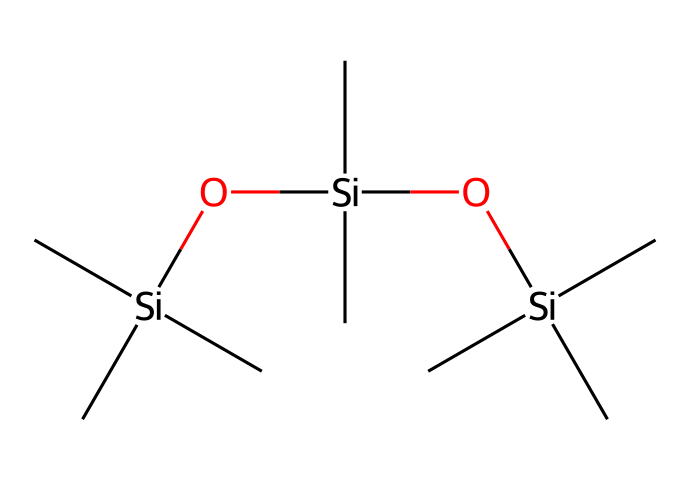What elements are present in this compound? The chemical structure consists of silicon (Si), carbon (C), and oxygen (O) atoms. The presence of carbon chains attached to silicon atoms confirms this.
Answer: silicon, carbon, oxygen How many silicon atoms are in the structure? By analyzing the SMILES representation, we identify three silicon atoms indicated by the 'Si' notation, each linked to carbon and oxygen components.
Answer: three What functional groups are indicated in the chemical? The structure contains hydroxy (-OH) groups represented by the oxygen atoms bonded to silicon. This suggests the presence of silanol functionalities.
Answer: silanol What is the degree of branching in this molecule? The presence of multiple carbon groups (C) attached to each silicon atom indicates a highly branched structure. Specifically, each silicon is attached to three methyl groups, showing significant branching.
Answer: highly branched What type of interaction is likely affected by the molecular arrangement in textiles? Given the silicon-oxygen backbone in this structure and the presence of hydrophilic (water-attracting) silanol groups, the interactions likely relate to water repellency and surface durability in fabric treatments.
Answer: water repellency What characteristic property might this compound impart to a football jersey? The presence of silicon-based compounds generally enhances properties like flexibility and water resistance in textiles, making the football jersey more durable and breathable.
Answer: flexibility and water resistance 